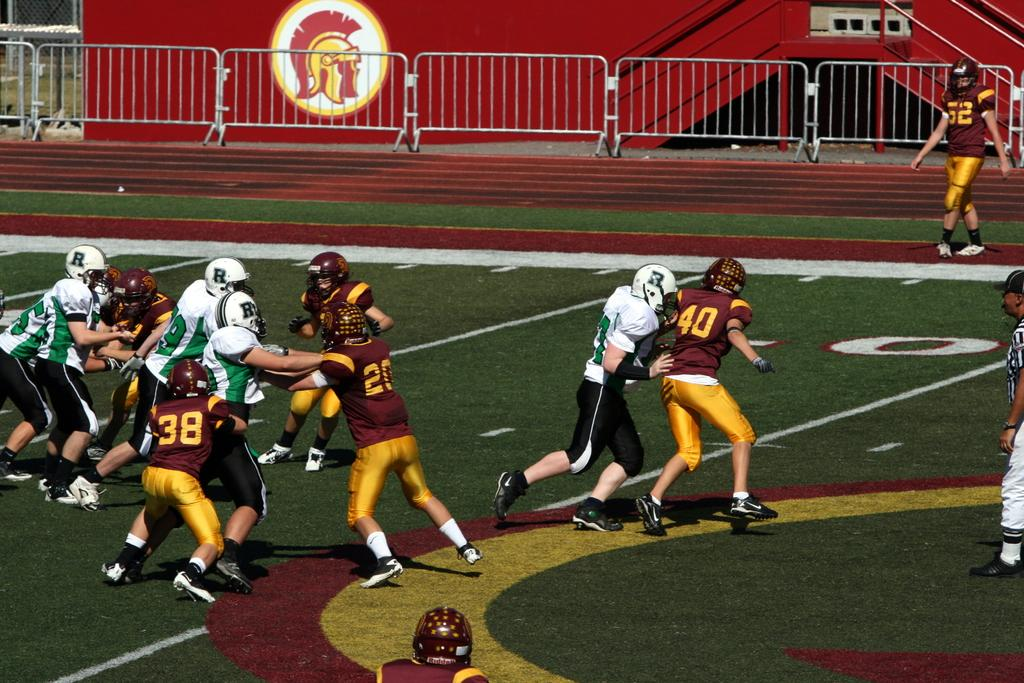What are the people in the image doing? The people in the image are playing on the ground. What is the surface they are playing on? The ground is covered with grass. What can be seen in the background of the image? There is fencing and a red color wall in the image. Is there any artwork or image on the red wall? Yes, there is an image on the red color wall. What type of silk material is draped over the fencing in the image? There is no silk material present in the image; the fencing is visible without any draping. 